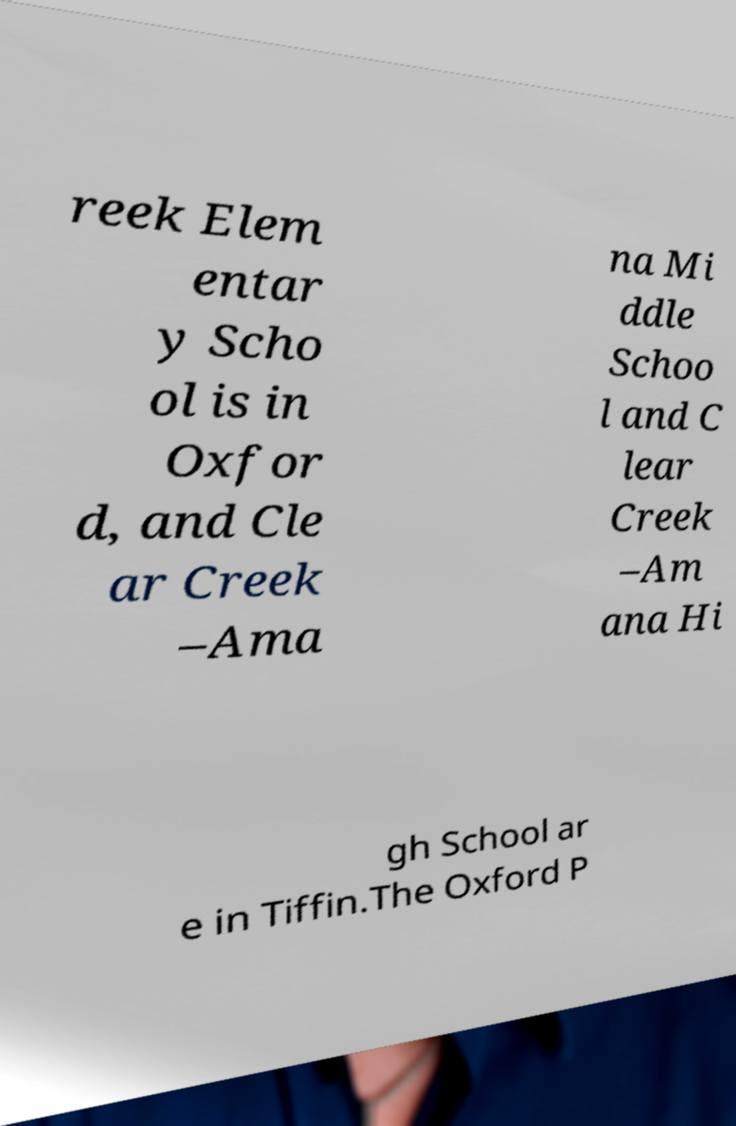I need the written content from this picture converted into text. Can you do that? reek Elem entar y Scho ol is in Oxfor d, and Cle ar Creek –Ama na Mi ddle Schoo l and C lear Creek –Am ana Hi gh School ar e in Tiffin.The Oxford P 